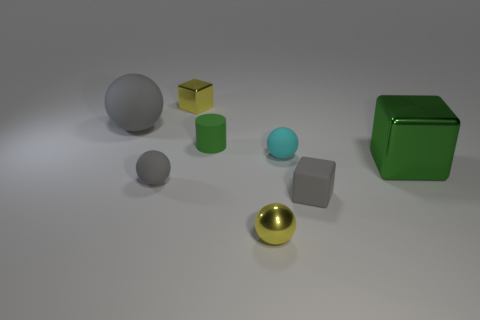Are there any tiny purple shiny cubes?
Offer a very short reply. No. What number of other objects are there of the same material as the tiny green thing?
Your answer should be very brief. 4. What is the material of the gray block that is the same size as the yellow metal sphere?
Your answer should be compact. Rubber. Does the gray matte thing right of the yellow block have the same shape as the small green matte thing?
Provide a short and direct response. No. Does the big rubber ball have the same color as the big block?
Offer a very short reply. No. How many things are either tiny matte things that are to the left of the small yellow metallic sphere or gray rubber blocks?
Give a very brief answer. 3. There is a cyan rubber object that is the same size as the green cylinder; what is its shape?
Offer a terse response. Sphere. There is a rubber object that is behind the small green cylinder; does it have the same size as the green object behind the cyan matte object?
Provide a short and direct response. No. There is a small ball that is the same material as the big green object; what is its color?
Your response must be concise. Yellow. Is the sphere that is behind the small matte cylinder made of the same material as the green thing behind the large metallic thing?
Ensure brevity in your answer.  Yes. 